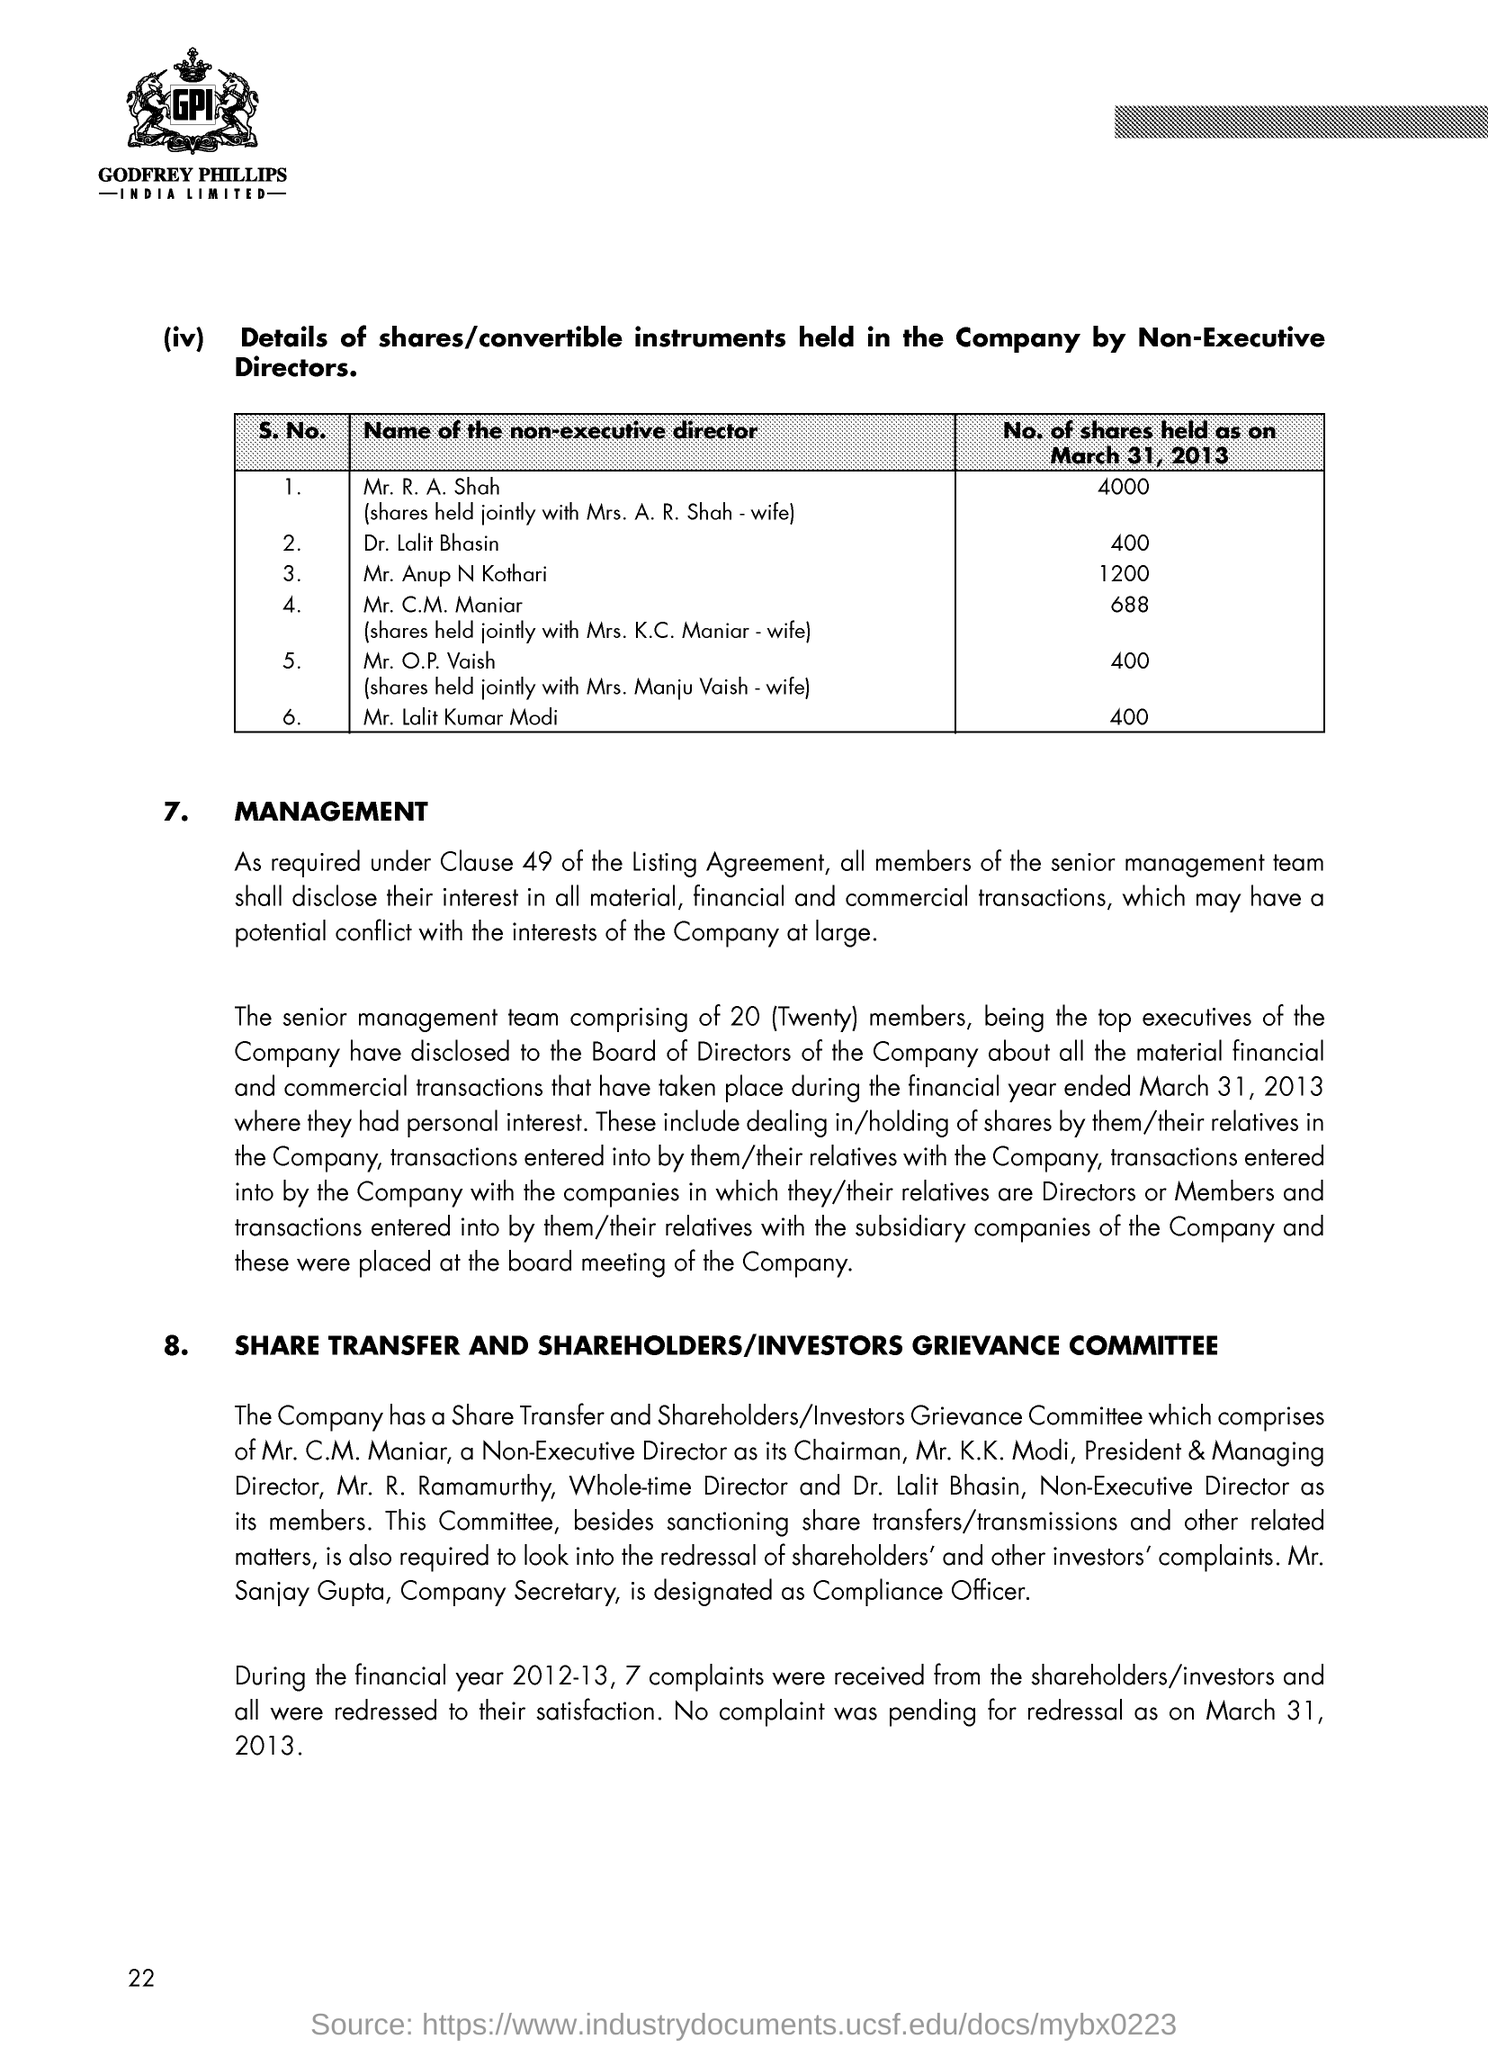Highlight a few significant elements in this photo. Mr. and Mrs. Maniar hold 688 shares in the company. Dr. Lalit Bhasin holds 400 shares in the company. I, Mr. Anup N Kothari, hold a share quantity of 1200 in this company. Mr. and Mrs. Shah hold 4000 shares in the company. According to the information provided, Mr. and Mrs. Vaish hold 400 shares in the company. 